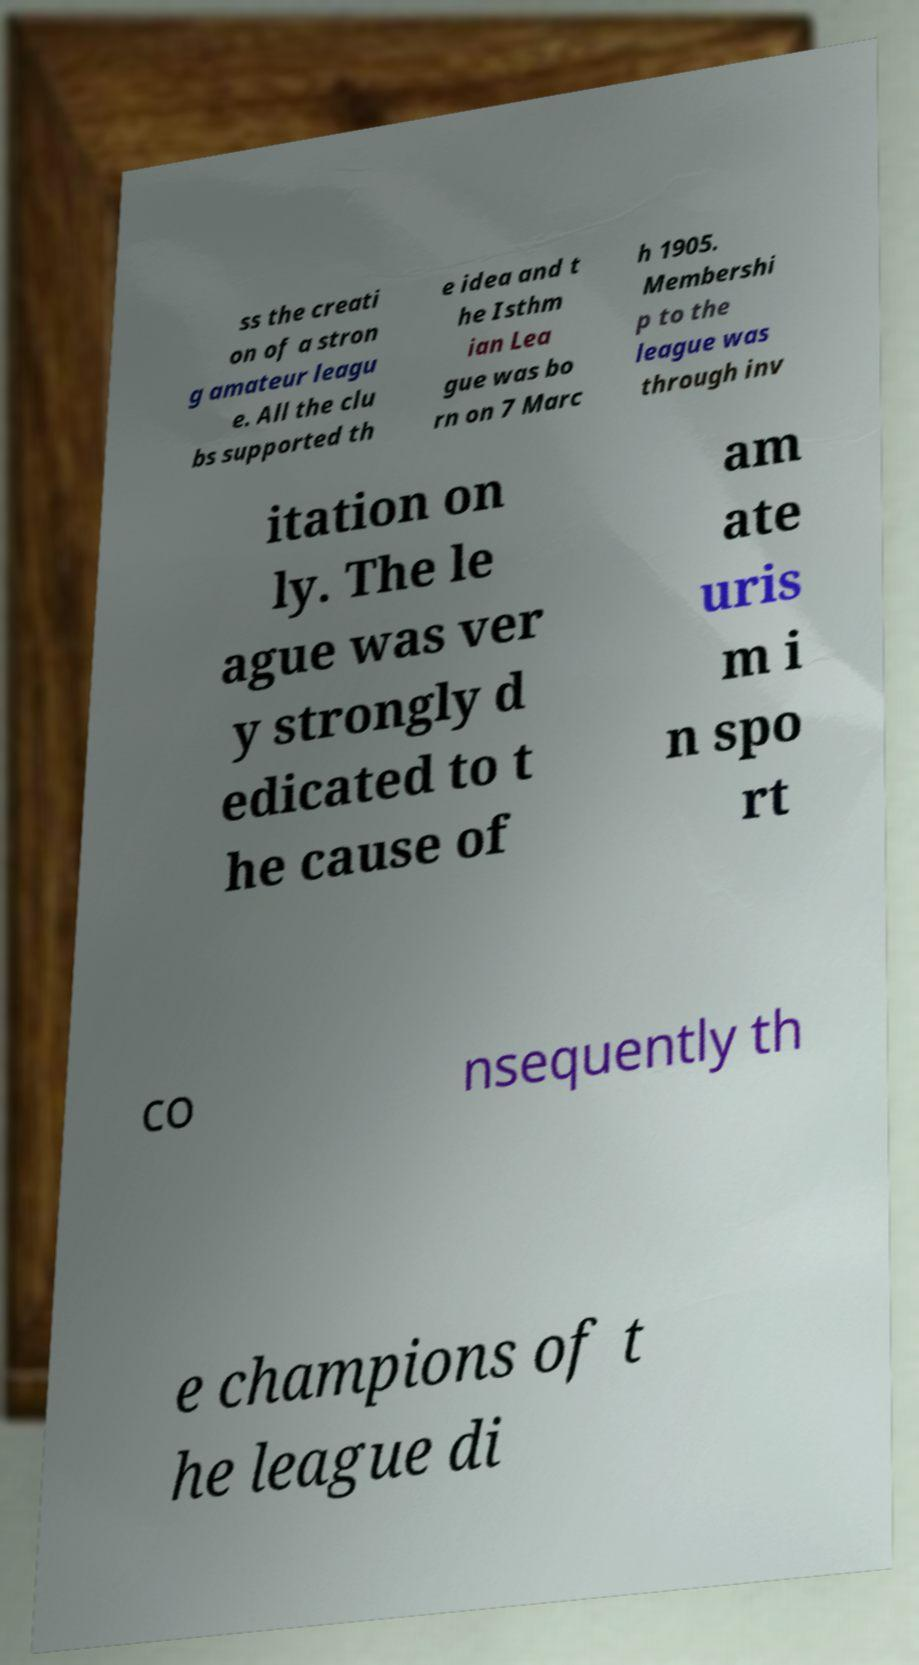Can you accurately transcribe the text from the provided image for me? ss the creati on of a stron g amateur leagu e. All the clu bs supported th e idea and t he Isthm ian Lea gue was bo rn on 7 Marc h 1905. Membershi p to the league was through inv itation on ly. The le ague was ver y strongly d edicated to t he cause of am ate uris m i n spo rt co nsequently th e champions of t he league di 